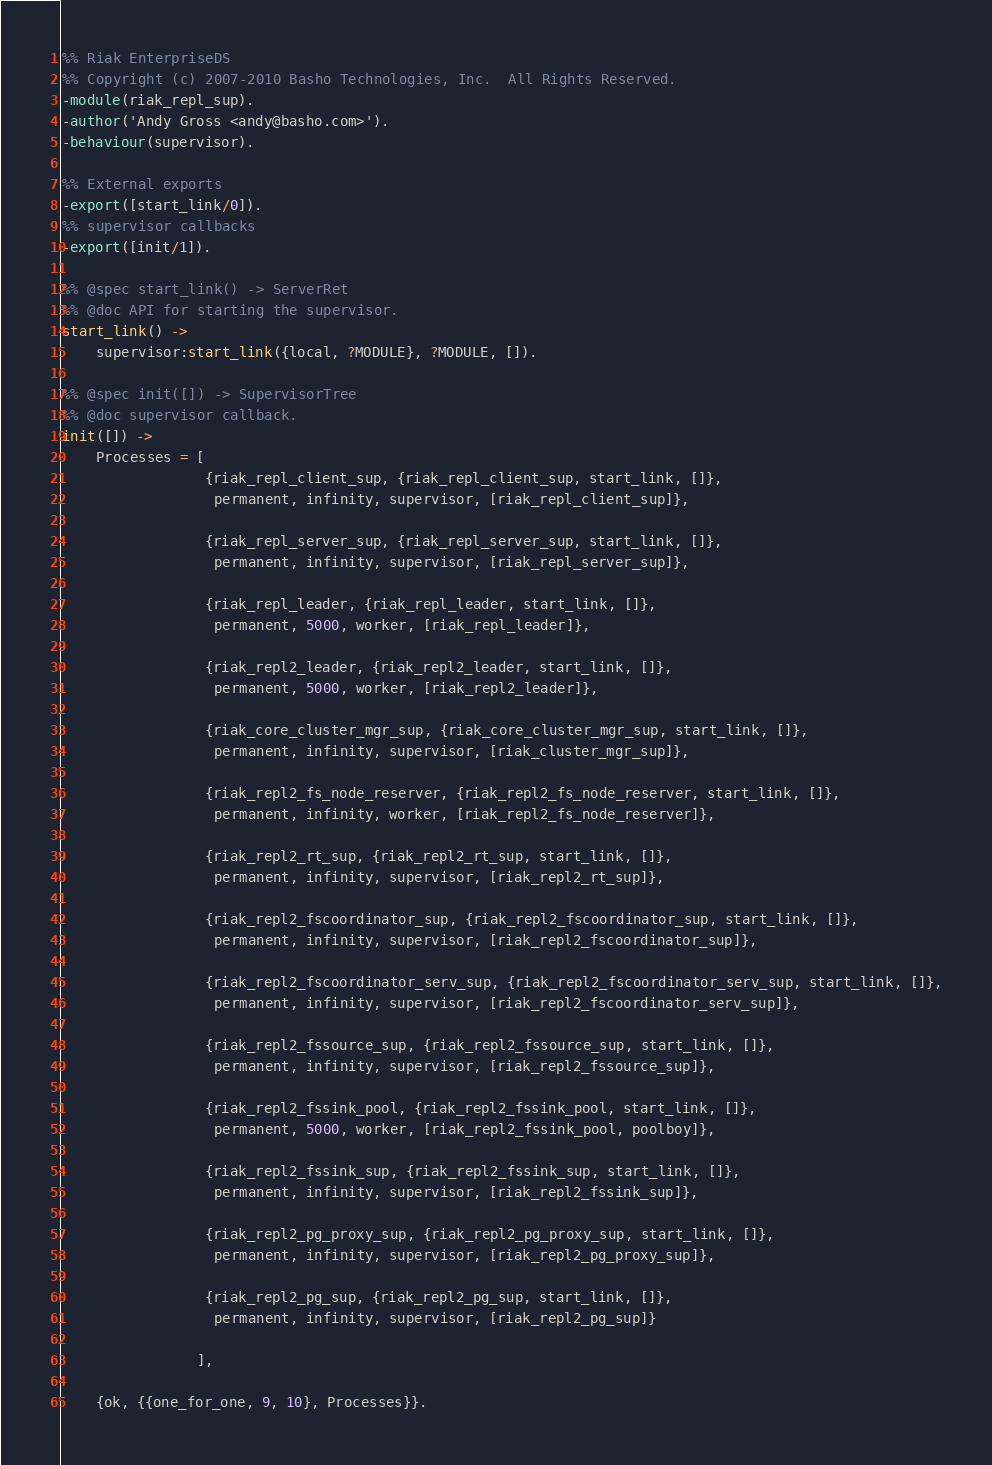<code> <loc_0><loc_0><loc_500><loc_500><_Erlang_>%% Riak EnterpriseDS
%% Copyright (c) 2007-2010 Basho Technologies, Inc.  All Rights Reserved.
-module(riak_repl_sup).
-author('Andy Gross <andy@basho.com>').
-behaviour(supervisor).

%% External exports
-export([start_link/0]).
%% supervisor callbacks
-export([init/1]).

%% @spec start_link() -> ServerRet
%% @doc API for starting the supervisor.
start_link() ->
    supervisor:start_link({local, ?MODULE}, ?MODULE, []).

%% @spec init([]) -> SupervisorTree
%% @doc supervisor callback.
init([]) ->
    Processes = [
                 {riak_repl_client_sup, {riak_repl_client_sup, start_link, []},
                  permanent, infinity, supervisor, [riak_repl_client_sup]},

                 {riak_repl_server_sup, {riak_repl_server_sup, start_link, []},
                  permanent, infinity, supervisor, [riak_repl_server_sup]},

                 {riak_repl_leader, {riak_repl_leader, start_link, []},
                  permanent, 5000, worker, [riak_repl_leader]},

                 {riak_repl2_leader, {riak_repl2_leader, start_link, []},
                  permanent, 5000, worker, [riak_repl2_leader]},

                 {riak_core_cluster_mgr_sup, {riak_core_cluster_mgr_sup, start_link, []},
                  permanent, infinity, supervisor, [riak_cluster_mgr_sup]},

                 {riak_repl2_fs_node_reserver, {riak_repl2_fs_node_reserver, start_link, []},
                  permanent, infinity, worker, [riak_repl2_fs_node_reserver]},

                 {riak_repl2_rt_sup, {riak_repl2_rt_sup, start_link, []},
                  permanent, infinity, supervisor, [riak_repl2_rt_sup]},

                 {riak_repl2_fscoordinator_sup, {riak_repl2_fscoordinator_sup, start_link, []},
                  permanent, infinity, supervisor, [riak_repl2_fscoordinator_sup]},

                 {riak_repl2_fscoordinator_serv_sup, {riak_repl2_fscoordinator_serv_sup, start_link, []},
                  permanent, infinity, supervisor, [riak_repl2_fscoordinator_serv_sup]},

                 {riak_repl2_fssource_sup, {riak_repl2_fssource_sup, start_link, []},
                  permanent, infinity, supervisor, [riak_repl2_fssource_sup]},

                 {riak_repl2_fssink_pool, {riak_repl2_fssink_pool, start_link, []},
                  permanent, 5000, worker, [riak_repl2_fssink_pool, poolboy]},

                 {riak_repl2_fssink_sup, {riak_repl2_fssink_sup, start_link, []},
                  permanent, infinity, supervisor, [riak_repl2_fssink_sup]},

                 {riak_repl2_pg_proxy_sup, {riak_repl2_pg_proxy_sup, start_link, []},
                  permanent, infinity, supervisor, [riak_repl2_pg_proxy_sup]},

                 {riak_repl2_pg_sup, {riak_repl2_pg_sup, start_link, []},
                  permanent, infinity, supervisor, [riak_repl2_pg_sup]}

                ],

    {ok, {{one_for_one, 9, 10}, Processes}}.

</code> 